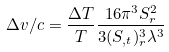Convert formula to latex. <formula><loc_0><loc_0><loc_500><loc_500>\Delta v / c = \frac { \Delta T } { T } \frac { 1 6 \pi ^ { 3 } S _ { r } ^ { 2 } } { 3 ( S _ { , t } ) _ { r } ^ { 3 } \lambda ^ { 3 } }</formula> 